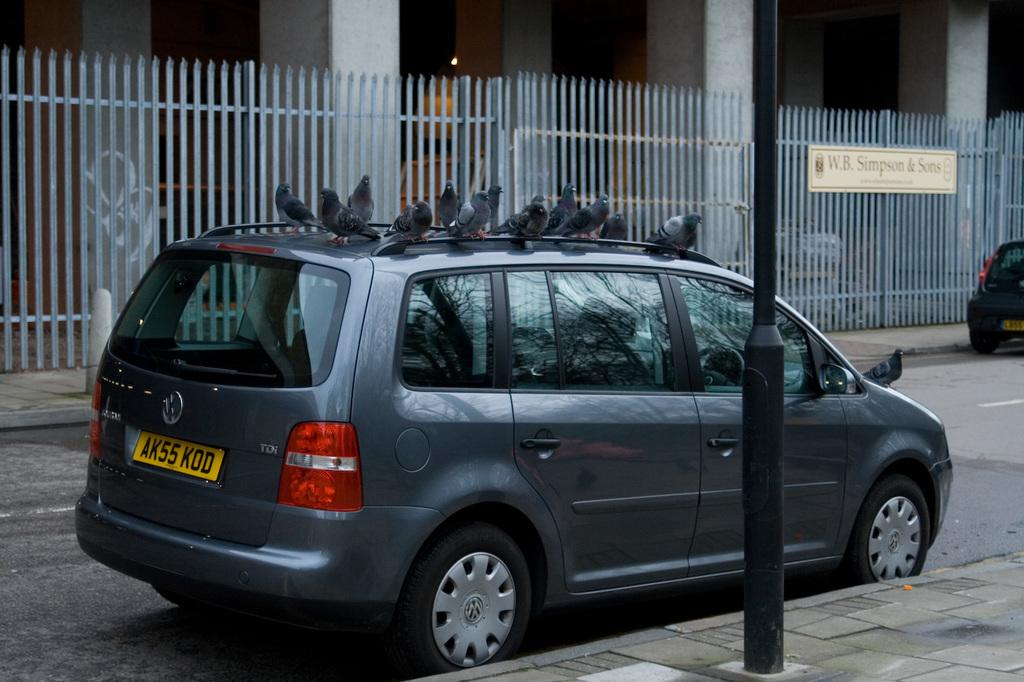Provide a one-sentence caption for the provided image. a van that has the letters AK on the back. 